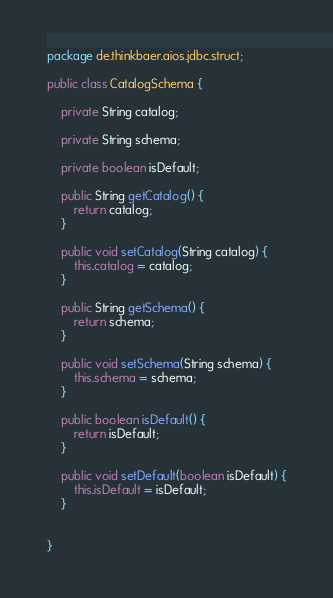<code> <loc_0><loc_0><loc_500><loc_500><_Java_>package de.thinkbaer.aios.jdbc.struct;

public class CatalogSchema {

	private String catalog;
	
	private String schema;
	
	private boolean isDefault;

	public String getCatalog() {
		return catalog;
	}

	public void setCatalog(String catalog) {
		this.catalog = catalog;
	}

	public String getSchema() {
		return schema;
	}

	public void setSchema(String schema) {
		this.schema = schema;
	}

	public boolean isDefault() {
		return isDefault;
	}

	public void setDefault(boolean isDefault) {
		this.isDefault = isDefault;
	}
	
	
}
</code> 